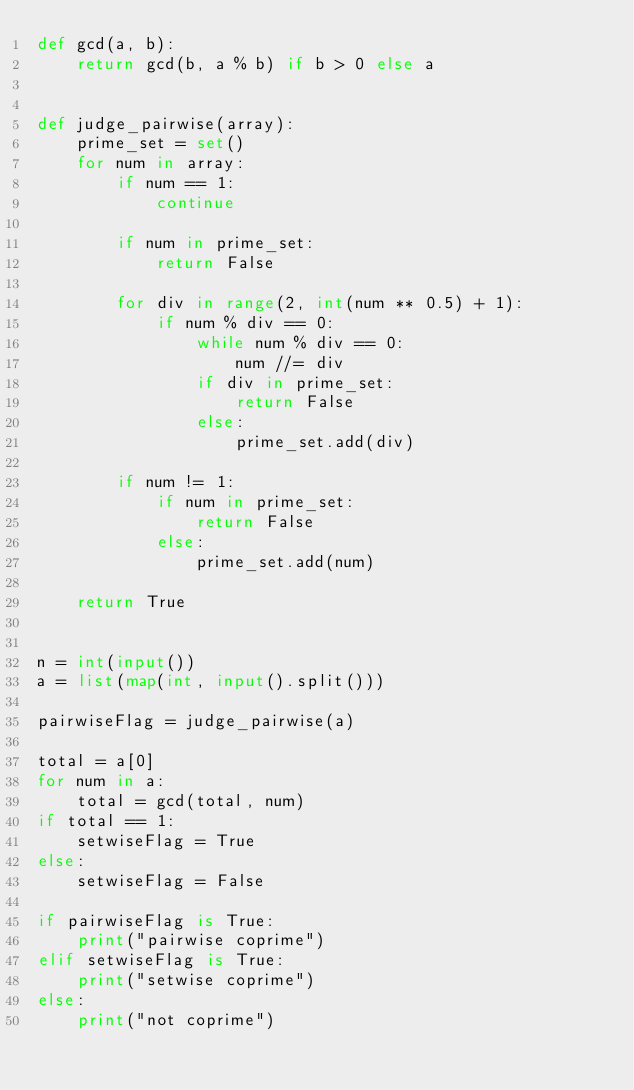Convert code to text. <code><loc_0><loc_0><loc_500><loc_500><_Python_>def gcd(a, b):
    return gcd(b, a % b) if b > 0 else a


def judge_pairwise(array):
    prime_set = set()
    for num in array:
        if num == 1:
            continue

        if num in prime_set:
            return False

        for div in range(2, int(num ** 0.5) + 1):
            if num % div == 0:
                while num % div == 0:
                    num //= div
                if div in prime_set:
                    return False
                else:
                    prime_set.add(div)

        if num != 1:
            if num in prime_set:
                return False
            else:
                prime_set.add(num)

    return True


n = int(input())
a = list(map(int, input().split()))

pairwiseFlag = judge_pairwise(a)

total = a[0]
for num in a:
    total = gcd(total, num)
if total == 1:
    setwiseFlag = True
else:
    setwiseFlag = False

if pairwiseFlag is True:
    print("pairwise coprime")
elif setwiseFlag is True:
    print("setwise coprime")
else:
    print("not coprime")
</code> 